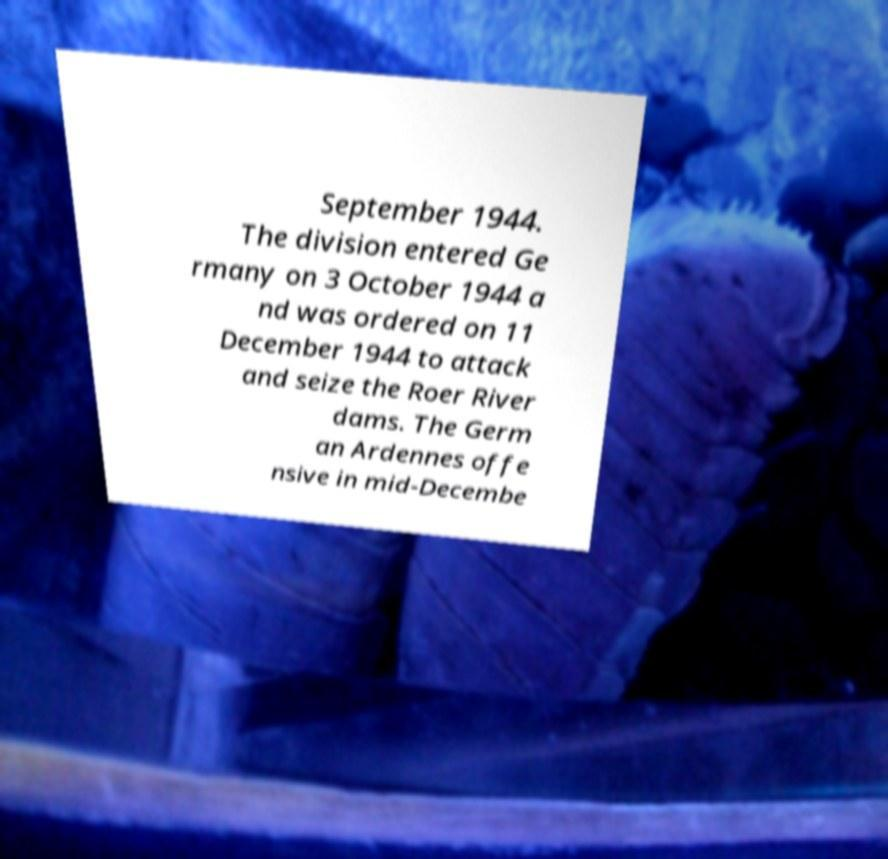Please read and relay the text visible in this image. What does it say? September 1944. The division entered Ge rmany on 3 October 1944 a nd was ordered on 11 December 1944 to attack and seize the Roer River dams. The Germ an Ardennes offe nsive in mid-Decembe 